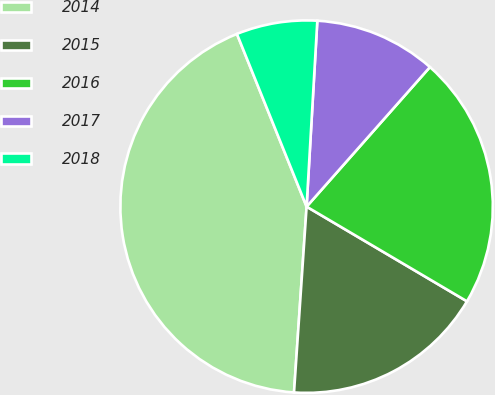Convert chart. <chart><loc_0><loc_0><loc_500><loc_500><pie_chart><fcel>2014<fcel>2015<fcel>2016<fcel>2017<fcel>2018<nl><fcel>42.82%<fcel>17.59%<fcel>21.97%<fcel>10.6%<fcel>7.02%<nl></chart> 